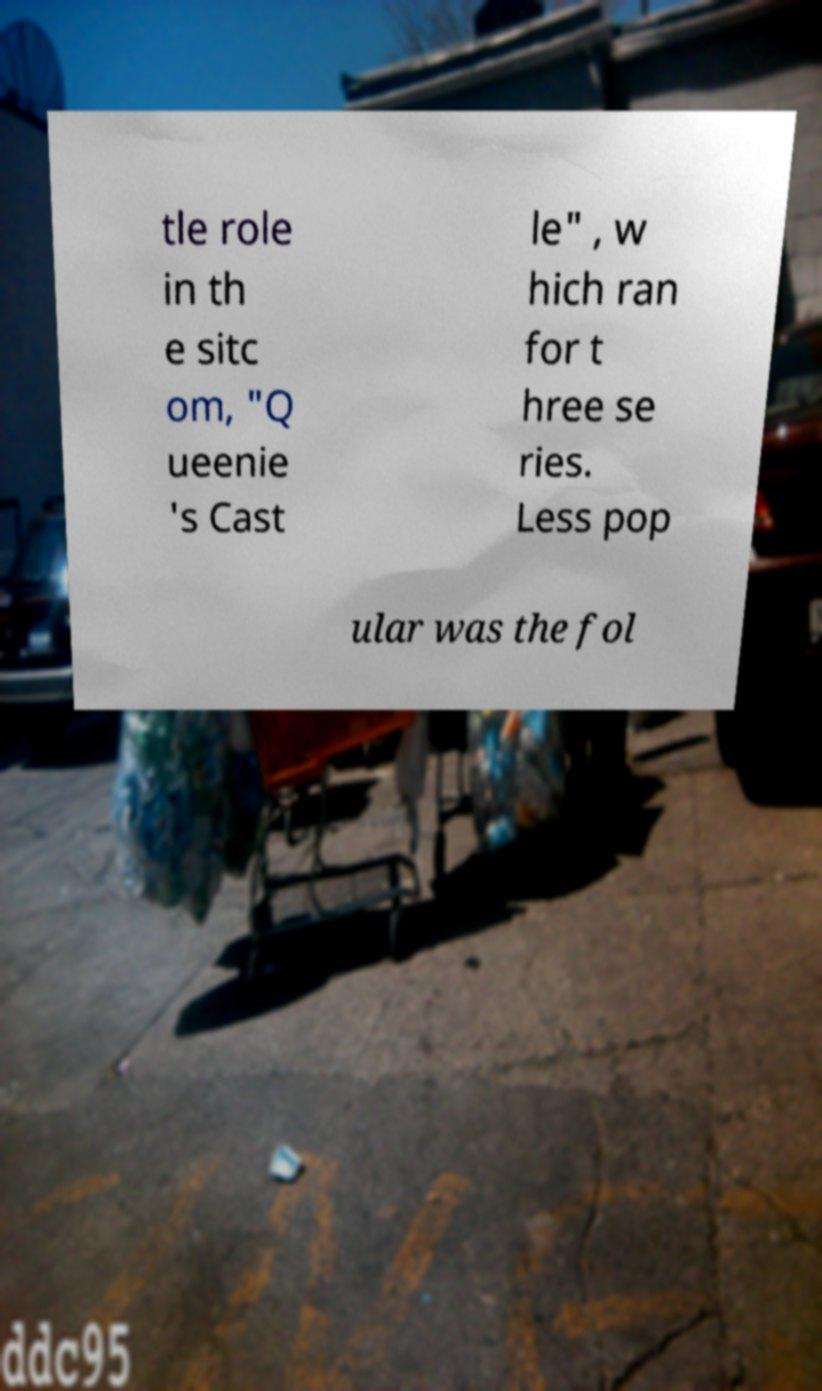Please read and relay the text visible in this image. What does it say? tle role in th e sitc om, "Q ueenie 's Cast le" , w hich ran for t hree se ries. Less pop ular was the fol 